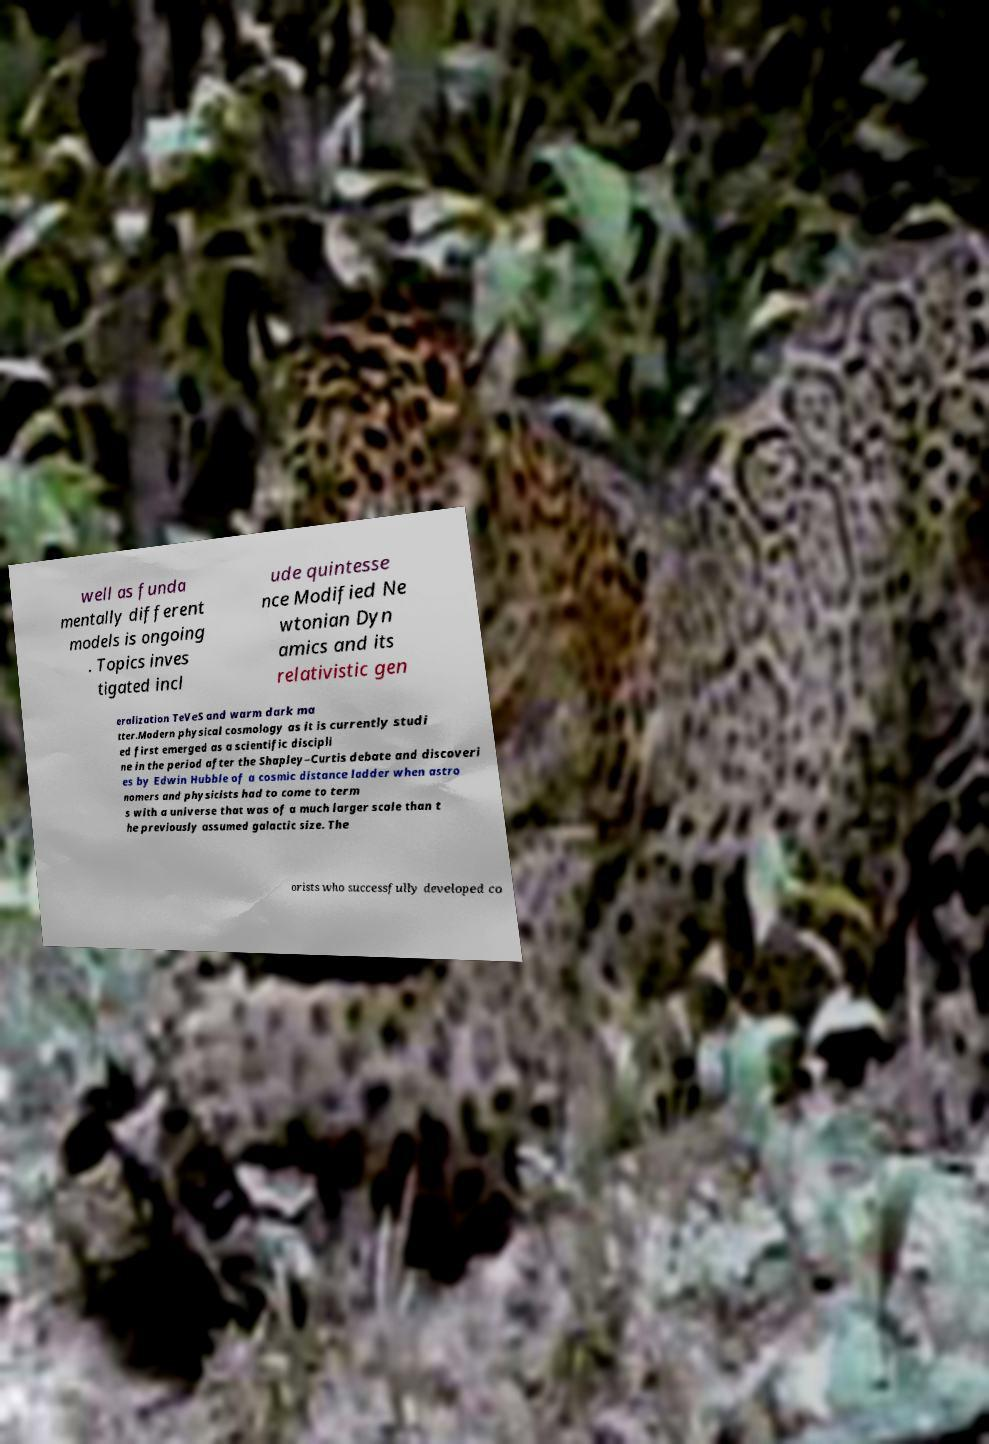What messages or text are displayed in this image? I need them in a readable, typed format. well as funda mentally different models is ongoing . Topics inves tigated incl ude quintesse nce Modified Ne wtonian Dyn amics and its relativistic gen eralization TeVeS and warm dark ma tter.Modern physical cosmology as it is currently studi ed first emerged as a scientific discipli ne in the period after the Shapley–Curtis debate and discoveri es by Edwin Hubble of a cosmic distance ladder when astro nomers and physicists had to come to term s with a universe that was of a much larger scale than t he previously assumed galactic size. The orists who successfully developed co 